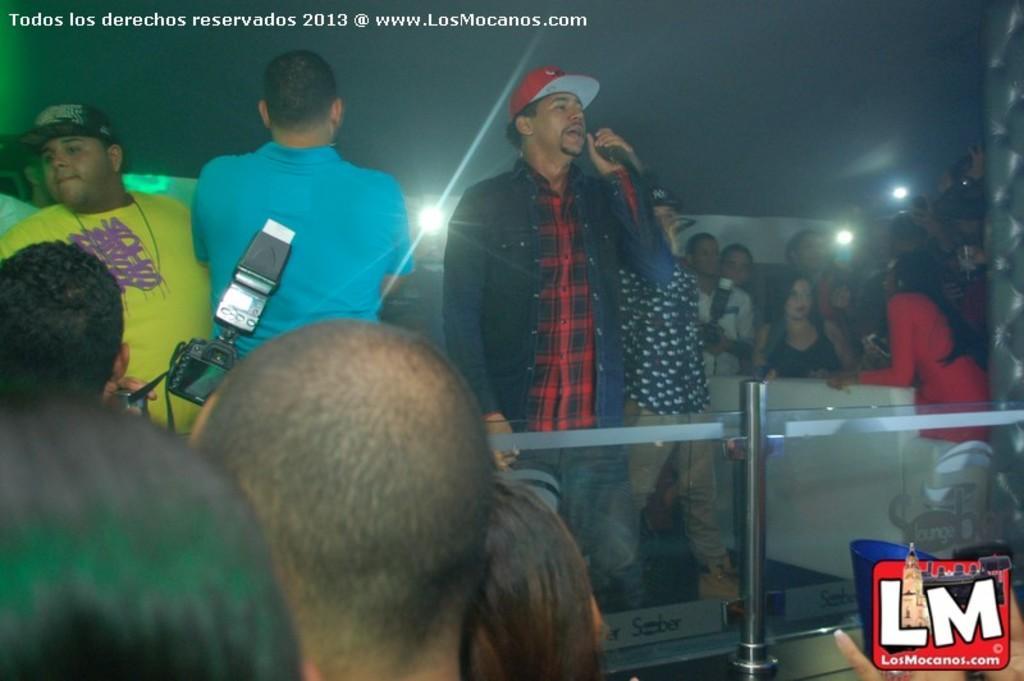How would you summarize this image in a sentence or two? In the picture we can see some people are standing and front of them, we can see a railing and behind it, we can see a man standing and talking into the microphone and beside him also we can see some people are standing and in the background also we can see some people are standing and behind them we can see a sky. 